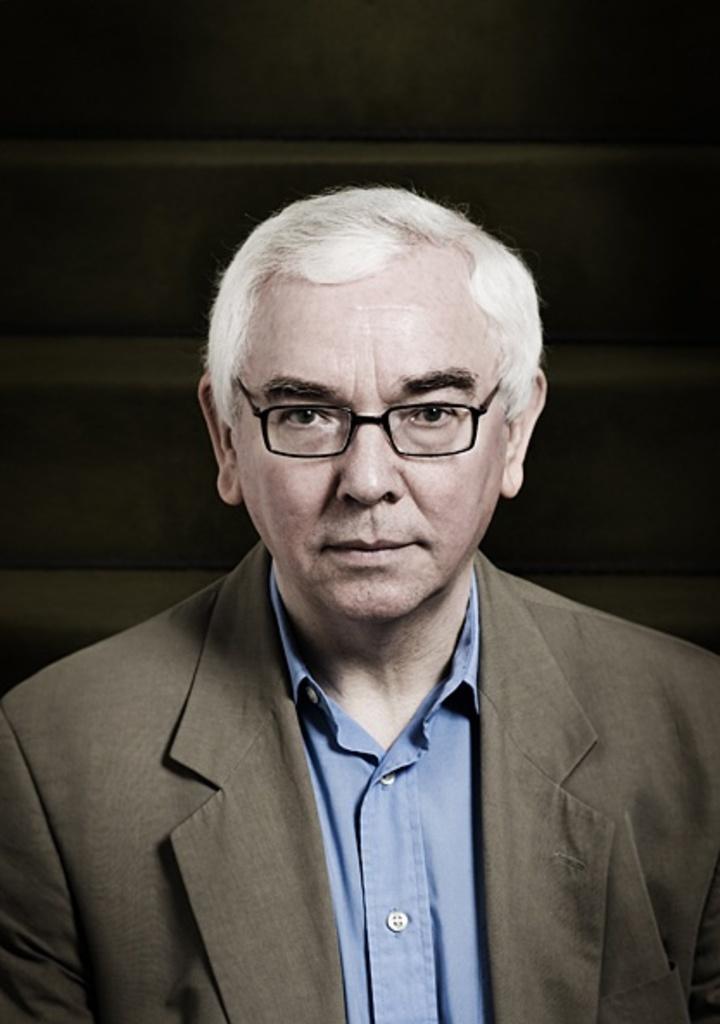In one or two sentences, can you explain what this image depicts? In this image there is a man. He is wearing spectacles, a blazer and a shirt. Behind him there is a wall. 